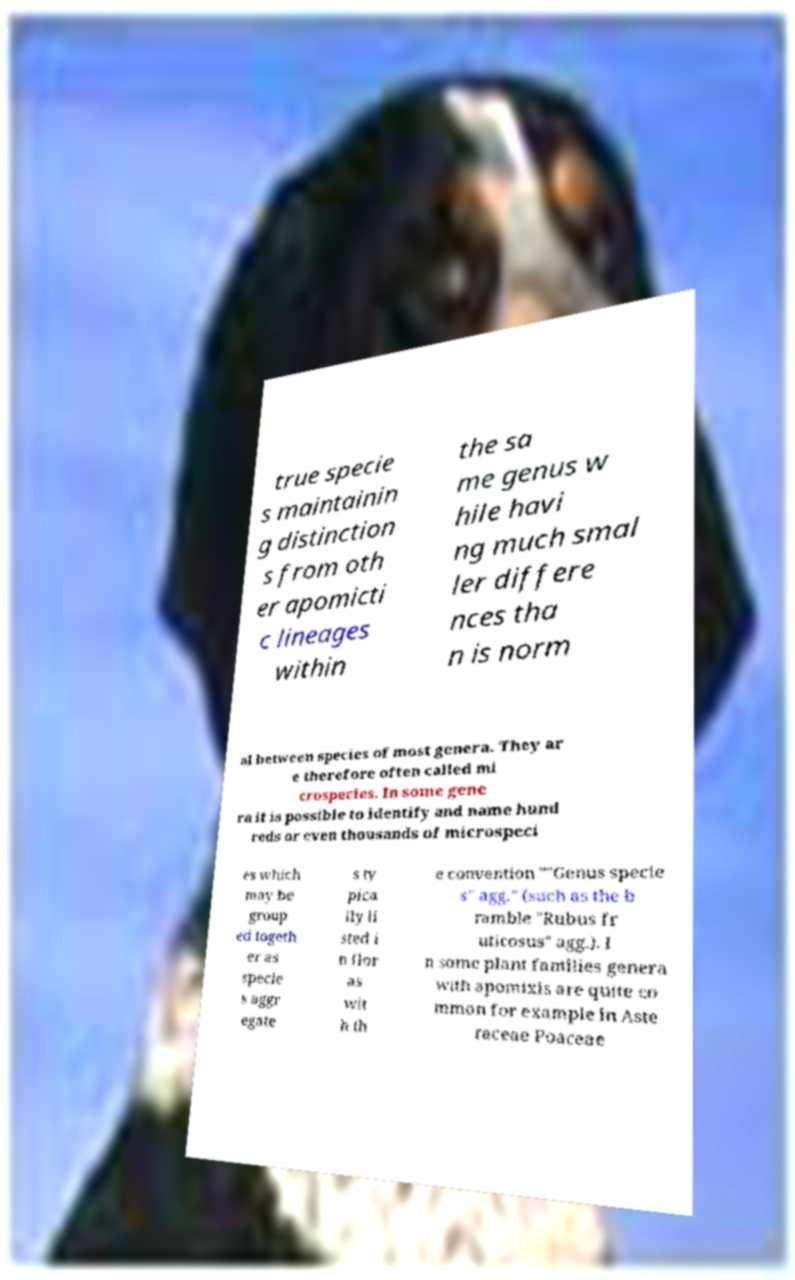Could you extract and type out the text from this image? true specie s maintainin g distinction s from oth er apomicti c lineages within the sa me genus w hile havi ng much smal ler differe nces tha n is norm al between species of most genera. They ar e therefore often called mi crospecies. In some gene ra it is possible to identify and name hund reds or even thousands of microspeci es which may be group ed togeth er as specie s aggr egate s ty pica lly li sted i n flor as wit h th e convention ""Genus specie s" agg." (such as the b ramble "Rubus fr uticosus" agg.). I n some plant families genera with apomixis are quite co mmon for example in Aste raceae Poaceae 